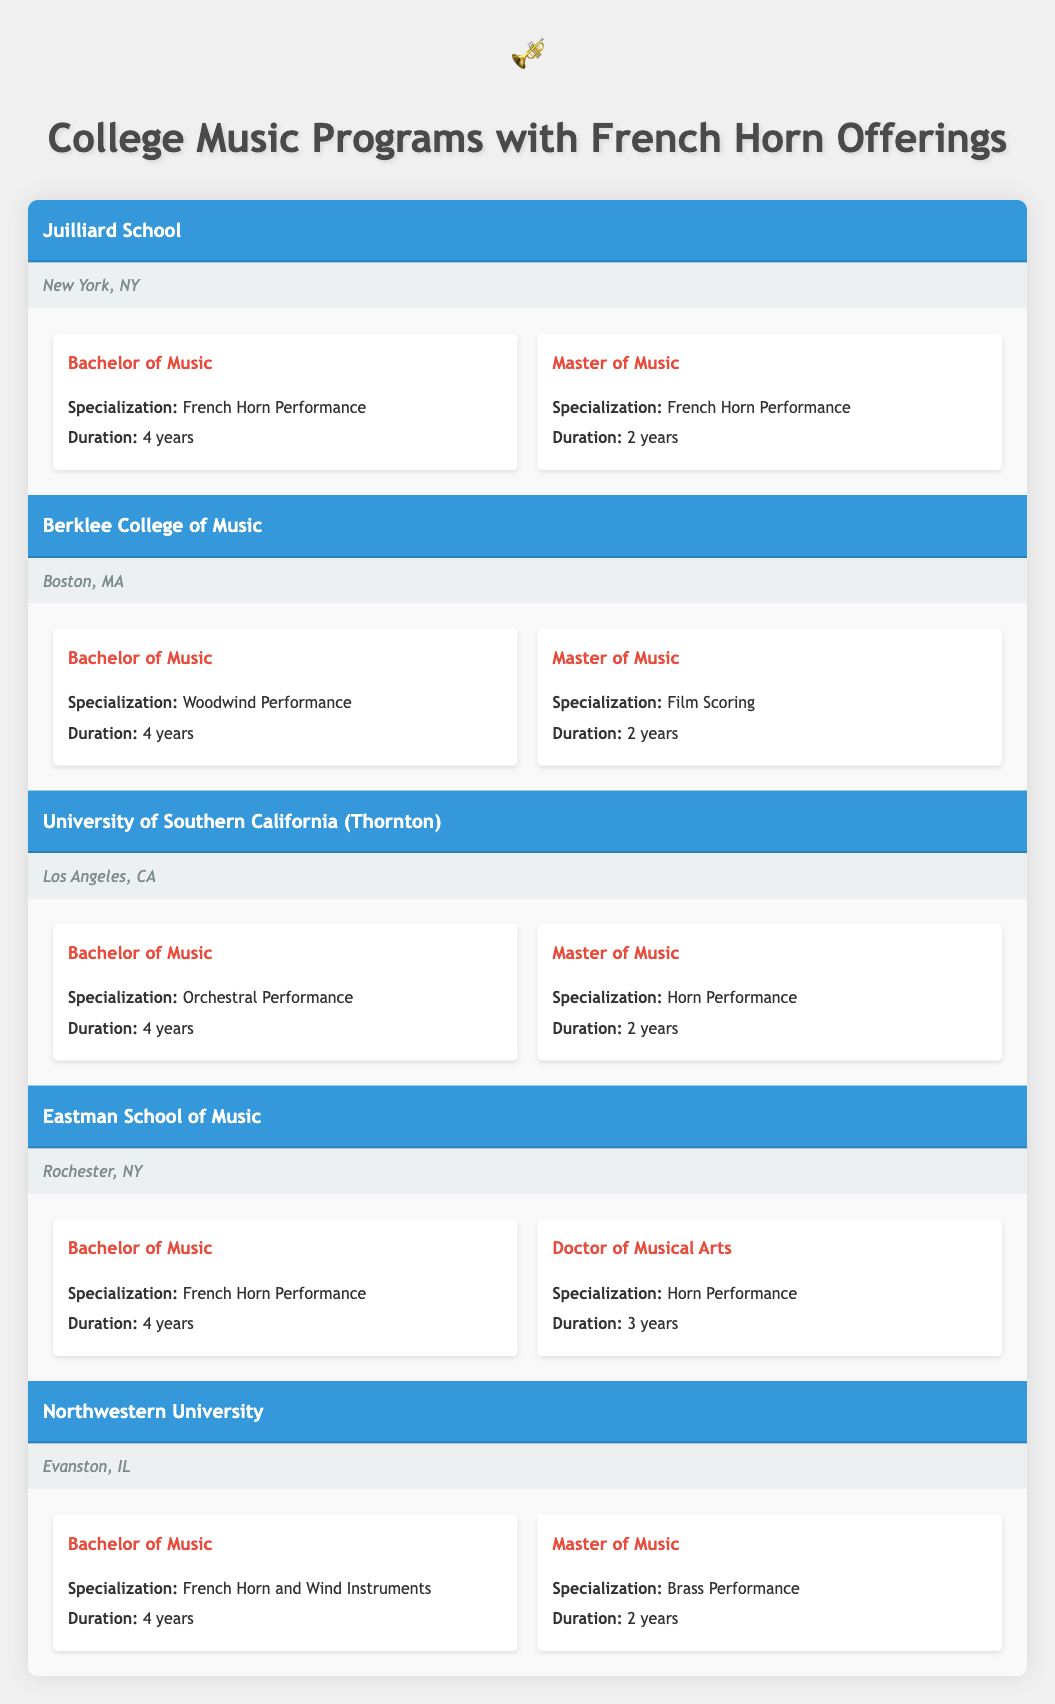What colleges offer a Bachelor of Music in French Horn Performance? There are two universities that offer a Bachelor of Music degree with a specialization in French Horn Performance: Juilliard School and Eastman School of Music.
Answer: Juilliard School, Eastman School of Music How long does it take to complete a Master of Music degree in French Horn Performance? According to the table, both Juilliard School and Eastman School of Music offer a Master of Music with a specialization in French Horn Performance, which takes 2 years to complete.
Answer: 2 years Is there a school offering a Doctor of Musical Arts in Horn Performance? The Eastman School of Music offers a Doctor of Musical Arts degree with a specialization in Horn Performance, making this statement true.
Answer: Yes What is the total number of universities listed in the table? There are 5 universities listed in the table: Juilliard School, Berklee College of Music, University of Southern California (Thornton), Eastman School of Music, and Northwestern University.
Answer: 5 Which university provides a specialization in Brass Performance for the Master of Music degree? Northwestern University offers a Master of Music in Brass Performance according to the table.
Answer: Northwestern University How many years does it take to earn the Doctor of Musical Arts degree? The Doctor of Musical Arts degree at Eastman School of Music takes 3 years to complete, as per the information in the table.
Answer: 3 years Which university has the location of Rochester, NY? The Eastman School of Music is located in Rochester, NY, as stated in the table.
Answer: Eastman School of Music Based on the information, how many institutions offer any form of French Horn Performance degree? The Juilliard School, Eastman School of Music, and University of Southern California (Thornton) all offer degree programs related to French Horn Performance. This gives a total of 3 institutions.
Answer: 3 